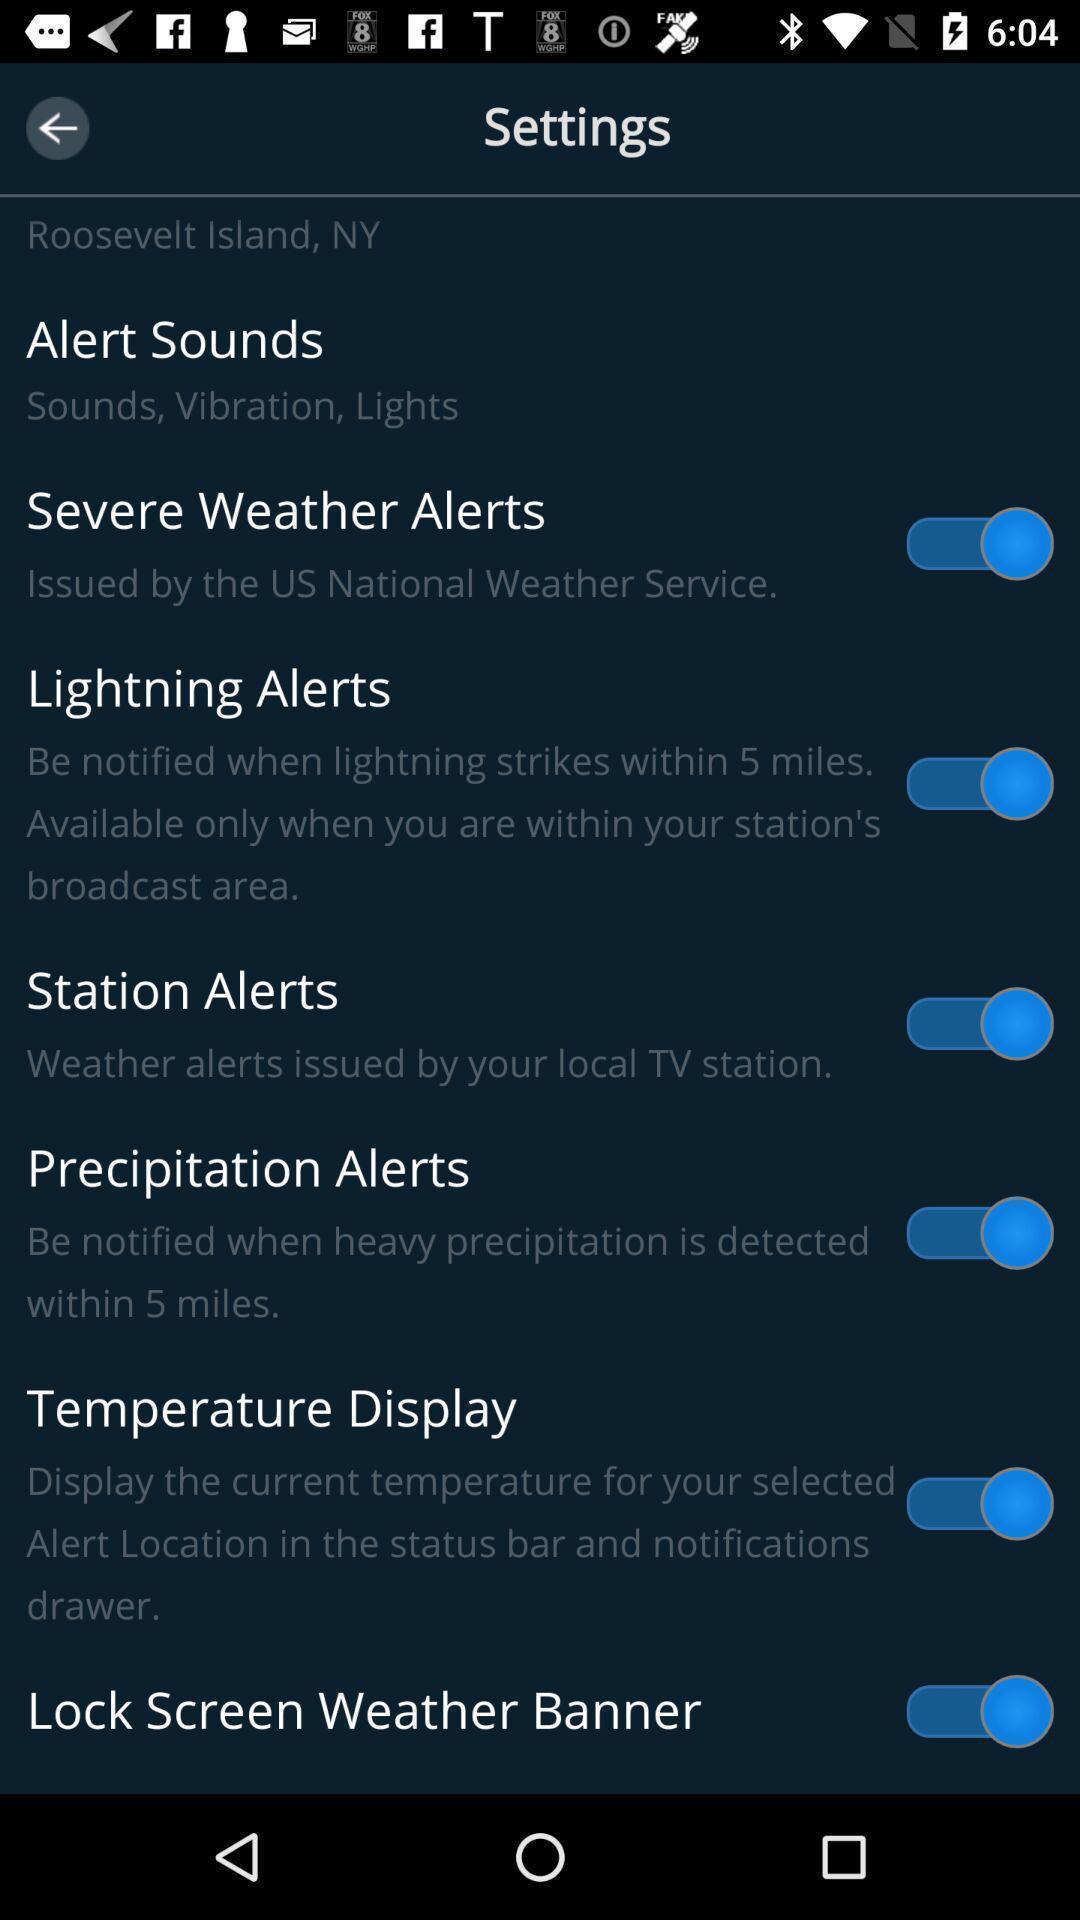Describe this image in words. Page showing general settings in a mobile. 